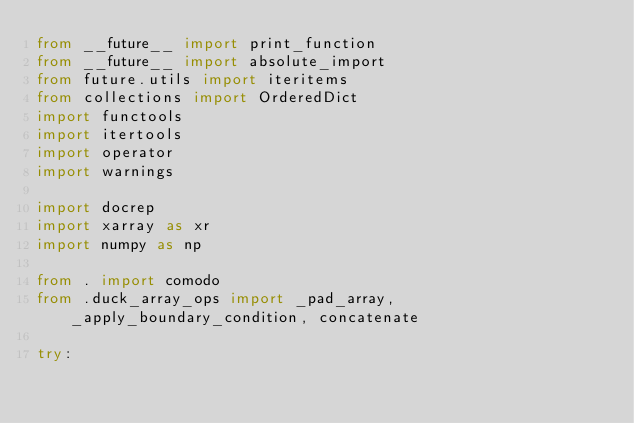Convert code to text. <code><loc_0><loc_0><loc_500><loc_500><_Python_>from __future__ import print_function
from __future__ import absolute_import
from future.utils import iteritems
from collections import OrderedDict
import functools
import itertools
import operator
import warnings

import docrep
import xarray as xr
import numpy as np

from . import comodo
from .duck_array_ops import _pad_array, _apply_boundary_condition, concatenate

try:</code> 